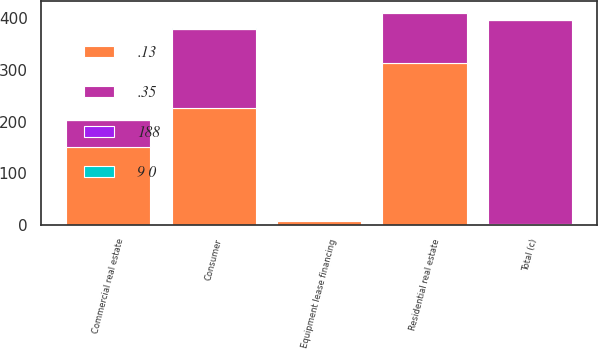<chart> <loc_0><loc_0><loc_500><loc_500><stacked_bar_chart><ecel><fcel>Commercial real estate<fcel>Equipment lease financing<fcel>Consumer<fcel>Residential real estate<fcel>Total (c)<nl><fcel>.13<fcel>150<fcel>6<fcel>226<fcel>314<fcel>2<nl><fcel>.35<fcel>52<fcel>2<fcel>154<fcel>97<fcel>395<nl><fcel>188<fcel>0.7<fcel>0.1<fcel>0.45<fcel>2.07<fcel>0.6<nl><fcel>9 0<fcel>0.22<fcel>0.03<fcel>0.32<fcel>0.62<fcel>0.24<nl></chart> 